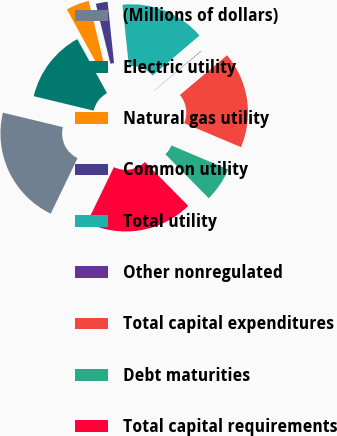Convert chart. <chart><loc_0><loc_0><loc_500><loc_500><pie_chart><fcel>(Millions of dollars)<fcel>Electric utility<fcel>Natural gas utility<fcel>Common utility<fcel>Total utility<fcel>Other nonregulated<fcel>Total capital expenditures<fcel>Debt maturities<fcel>Total capital requirements<nl><fcel>21.61%<fcel>13.22%<fcel>4.2%<fcel>2.14%<fcel>15.43%<fcel>0.08%<fcel>17.49%<fcel>6.26%<fcel>19.55%<nl></chart> 